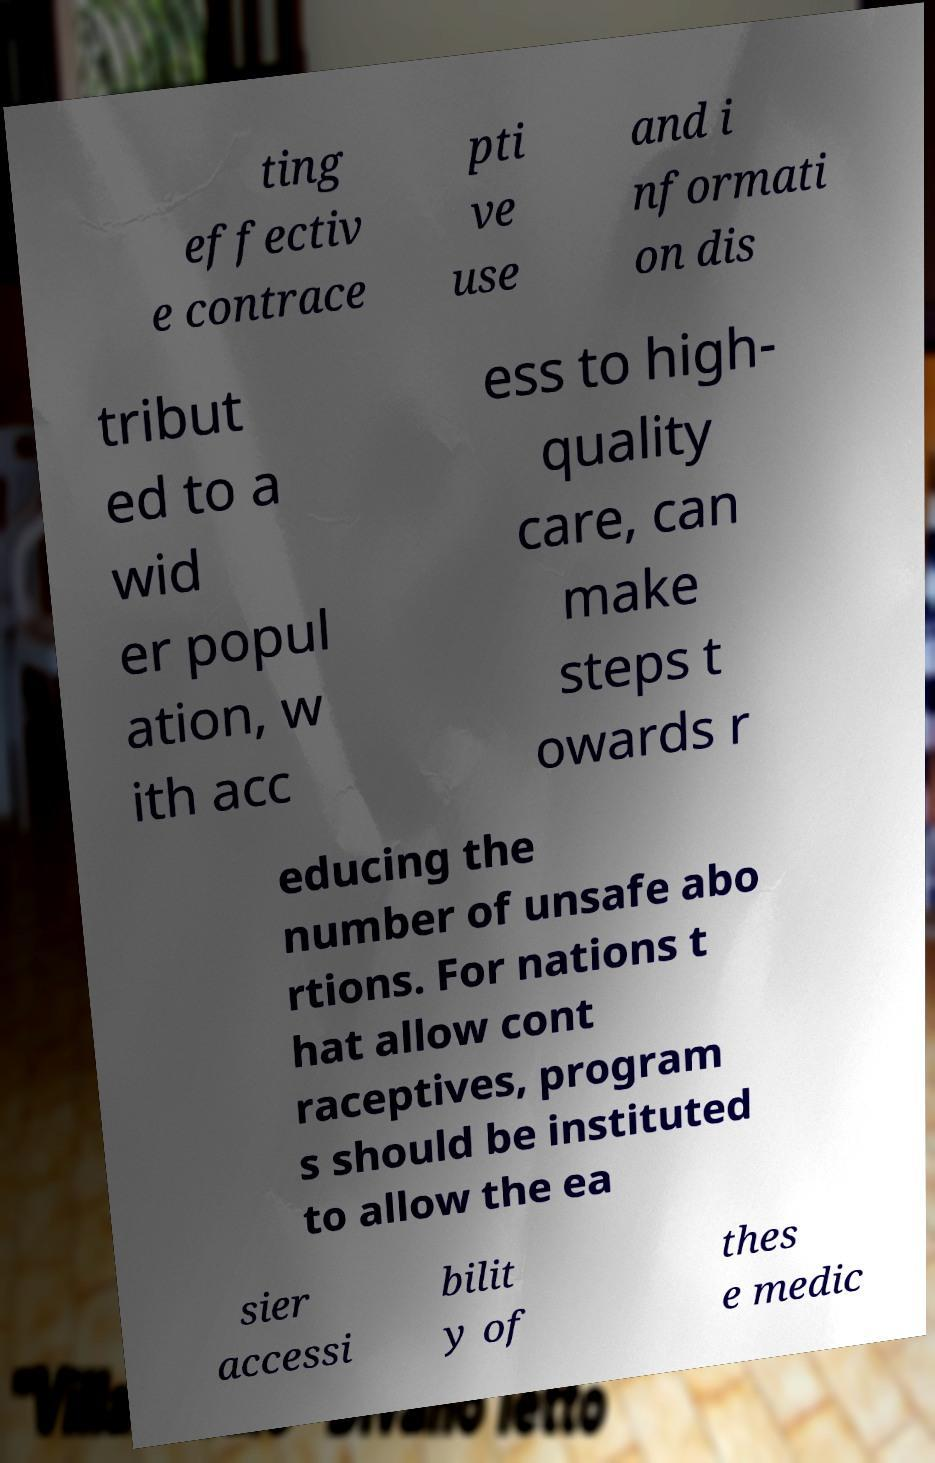Could you assist in decoding the text presented in this image and type it out clearly? ting effectiv e contrace pti ve use and i nformati on dis tribut ed to a wid er popul ation, w ith acc ess to high- quality care, can make steps t owards r educing the number of unsafe abo rtions. For nations t hat allow cont raceptives, program s should be instituted to allow the ea sier accessi bilit y of thes e medic 